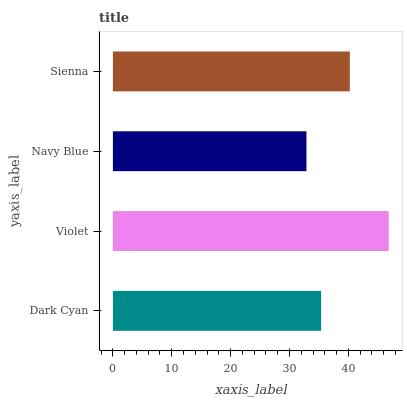Is Navy Blue the minimum?
Answer yes or no. Yes. Is Violet the maximum?
Answer yes or no. Yes. Is Violet the minimum?
Answer yes or no. No. Is Navy Blue the maximum?
Answer yes or no. No. Is Violet greater than Navy Blue?
Answer yes or no. Yes. Is Navy Blue less than Violet?
Answer yes or no. Yes. Is Navy Blue greater than Violet?
Answer yes or no. No. Is Violet less than Navy Blue?
Answer yes or no. No. Is Sienna the high median?
Answer yes or no. Yes. Is Dark Cyan the low median?
Answer yes or no. Yes. Is Violet the high median?
Answer yes or no. No. Is Sienna the low median?
Answer yes or no. No. 